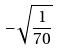Convert formula to latex. <formula><loc_0><loc_0><loc_500><loc_500>- \sqrt { \frac { 1 } { 7 0 } }</formula> 